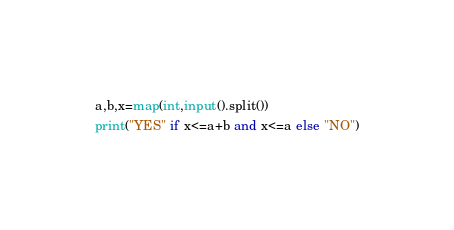<code> <loc_0><loc_0><loc_500><loc_500><_Python_>a,b,x=map(int,input().split())
print("YES" if x<=a+b and x<=a else "NO")</code> 